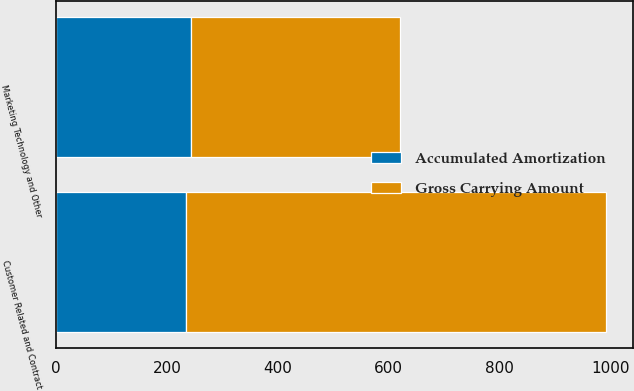<chart> <loc_0><loc_0><loc_500><loc_500><stacked_bar_chart><ecel><fcel>Customer Related and Contract<fcel>Marketing Technology and Other<nl><fcel>Gross Carrying Amount<fcel>757<fcel>376<nl><fcel>Accumulated Amortization<fcel>234<fcel>244<nl></chart> 